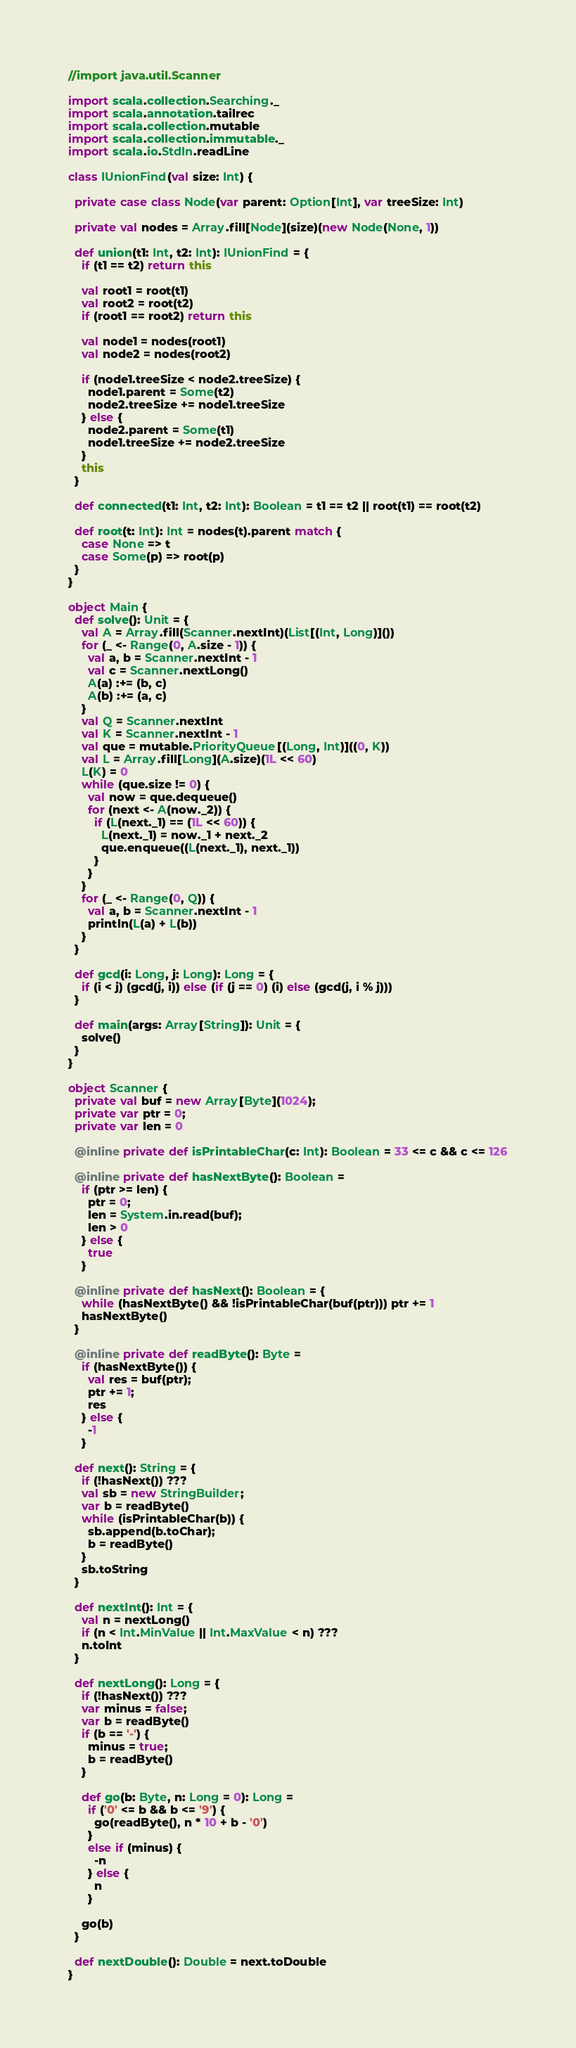Convert code to text. <code><loc_0><loc_0><loc_500><loc_500><_Scala_>//import java.util.Scanner

import scala.collection.Searching._
import scala.annotation.tailrec
import scala.collection.mutable
import scala.collection.immutable._
import scala.io.StdIn.readLine

class IUnionFind(val size: Int) {

  private case class Node(var parent: Option[Int], var treeSize: Int)

  private val nodes = Array.fill[Node](size)(new Node(None, 1))

  def union(t1: Int, t2: Int): IUnionFind = {
    if (t1 == t2) return this

    val root1 = root(t1)
    val root2 = root(t2)
    if (root1 == root2) return this

    val node1 = nodes(root1)
    val node2 = nodes(root2)

    if (node1.treeSize < node2.treeSize) {
      node1.parent = Some(t2)
      node2.treeSize += node1.treeSize
    } else {
      node2.parent = Some(t1)
      node1.treeSize += node2.treeSize
    }
    this
  }

  def connected(t1: Int, t2: Int): Boolean = t1 == t2 || root(t1) == root(t2)

  def root(t: Int): Int = nodes(t).parent match {
    case None => t
    case Some(p) => root(p)
  }
}

object Main {
  def solve(): Unit = {
    val A = Array.fill(Scanner.nextInt)(List[(Int, Long)]())
    for (_ <- Range(0, A.size - 1)) {
      val a, b = Scanner.nextInt - 1
      val c = Scanner.nextLong()
      A(a) :+= (b, c)
      A(b) :+= (a, c)
    }
    val Q = Scanner.nextInt
    val K = Scanner.nextInt - 1
    val que = mutable.PriorityQueue[(Long, Int)]((0, K))
    val L = Array.fill[Long](A.size)(1L << 60)
    L(K) = 0
    while (que.size != 0) {
      val now = que.dequeue()
      for (next <- A(now._2)) {
        if (L(next._1) == (1L << 60)) {
          L(next._1) = now._1 + next._2
          que.enqueue((L(next._1), next._1))
        }
      }
    }
    for (_ <- Range(0, Q)) {
      val a, b = Scanner.nextInt - 1
      println(L(a) + L(b))
    }
  }

  def gcd(i: Long, j: Long): Long = {
    if (i < j) (gcd(j, i)) else (if (j == 0) (i) else (gcd(j, i % j)))
  }

  def main(args: Array[String]): Unit = {
    solve()
  }
}

object Scanner {
  private val buf = new Array[Byte](1024);
  private var ptr = 0;
  private var len = 0

  @inline private def isPrintableChar(c: Int): Boolean = 33 <= c && c <= 126

  @inline private def hasNextByte(): Boolean =
    if (ptr >= len) {
      ptr = 0;
      len = System.in.read(buf);
      len > 0
    } else {
      true
    }

  @inline private def hasNext(): Boolean = {
    while (hasNextByte() && !isPrintableChar(buf(ptr))) ptr += 1
    hasNextByte()
  }

  @inline private def readByte(): Byte =
    if (hasNextByte()) {
      val res = buf(ptr);
      ptr += 1;
      res
    } else {
      -1
    }

  def next(): String = {
    if (!hasNext()) ???
    val sb = new StringBuilder;
    var b = readByte()
    while (isPrintableChar(b)) {
      sb.append(b.toChar);
      b = readByte()
    }
    sb.toString
  }

  def nextInt(): Int = {
    val n = nextLong()
    if (n < Int.MinValue || Int.MaxValue < n) ???
    n.toInt
  }

  def nextLong(): Long = {
    if (!hasNext()) ???
    var minus = false;
    var b = readByte()
    if (b == '-') {
      minus = true;
      b = readByte()
    }

    def go(b: Byte, n: Long = 0): Long =
      if ('0' <= b && b <= '9') {
        go(readByte(), n * 10 + b - '0')
      }
      else if (minus) {
        -n
      } else {
        n
      }

    go(b)
  }

  def nextDouble(): Double = next.toDouble
}</code> 